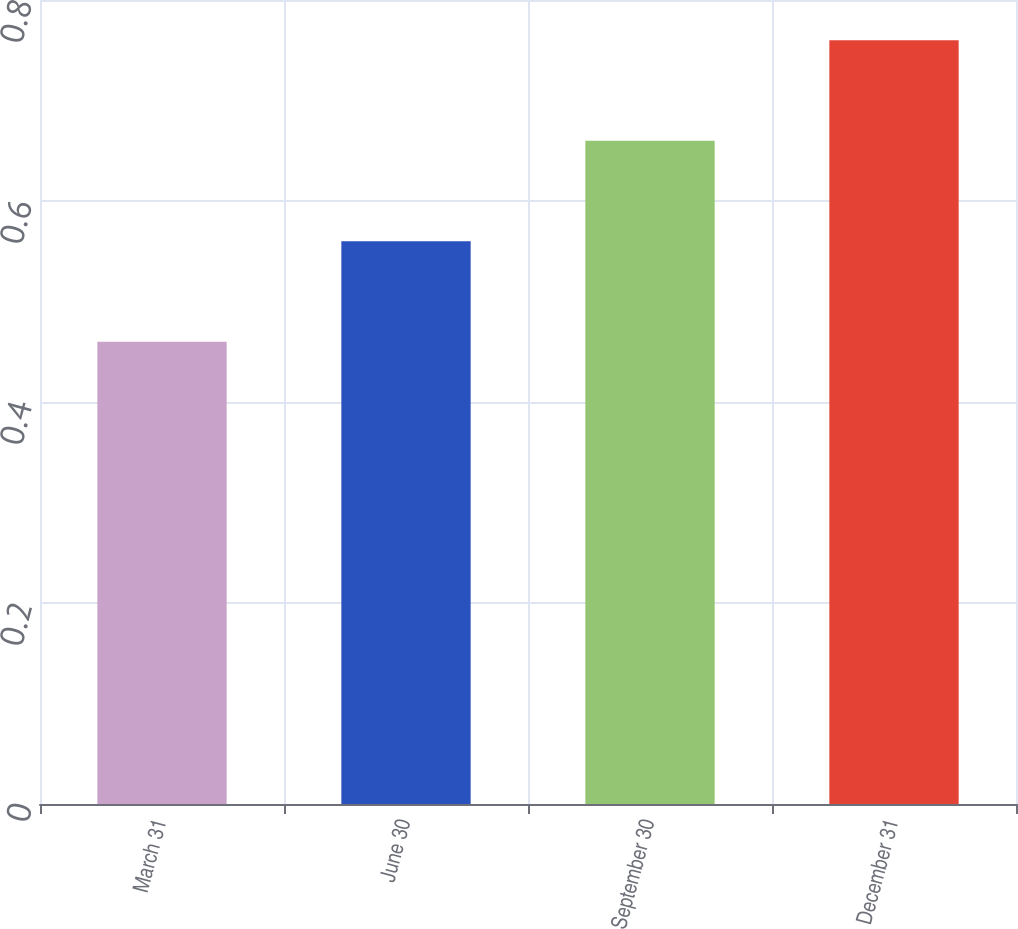<chart> <loc_0><loc_0><loc_500><loc_500><bar_chart><fcel>March 31<fcel>June 30<fcel>September 30<fcel>December 31<nl><fcel>0.46<fcel>0.56<fcel>0.66<fcel>0.76<nl></chart> 